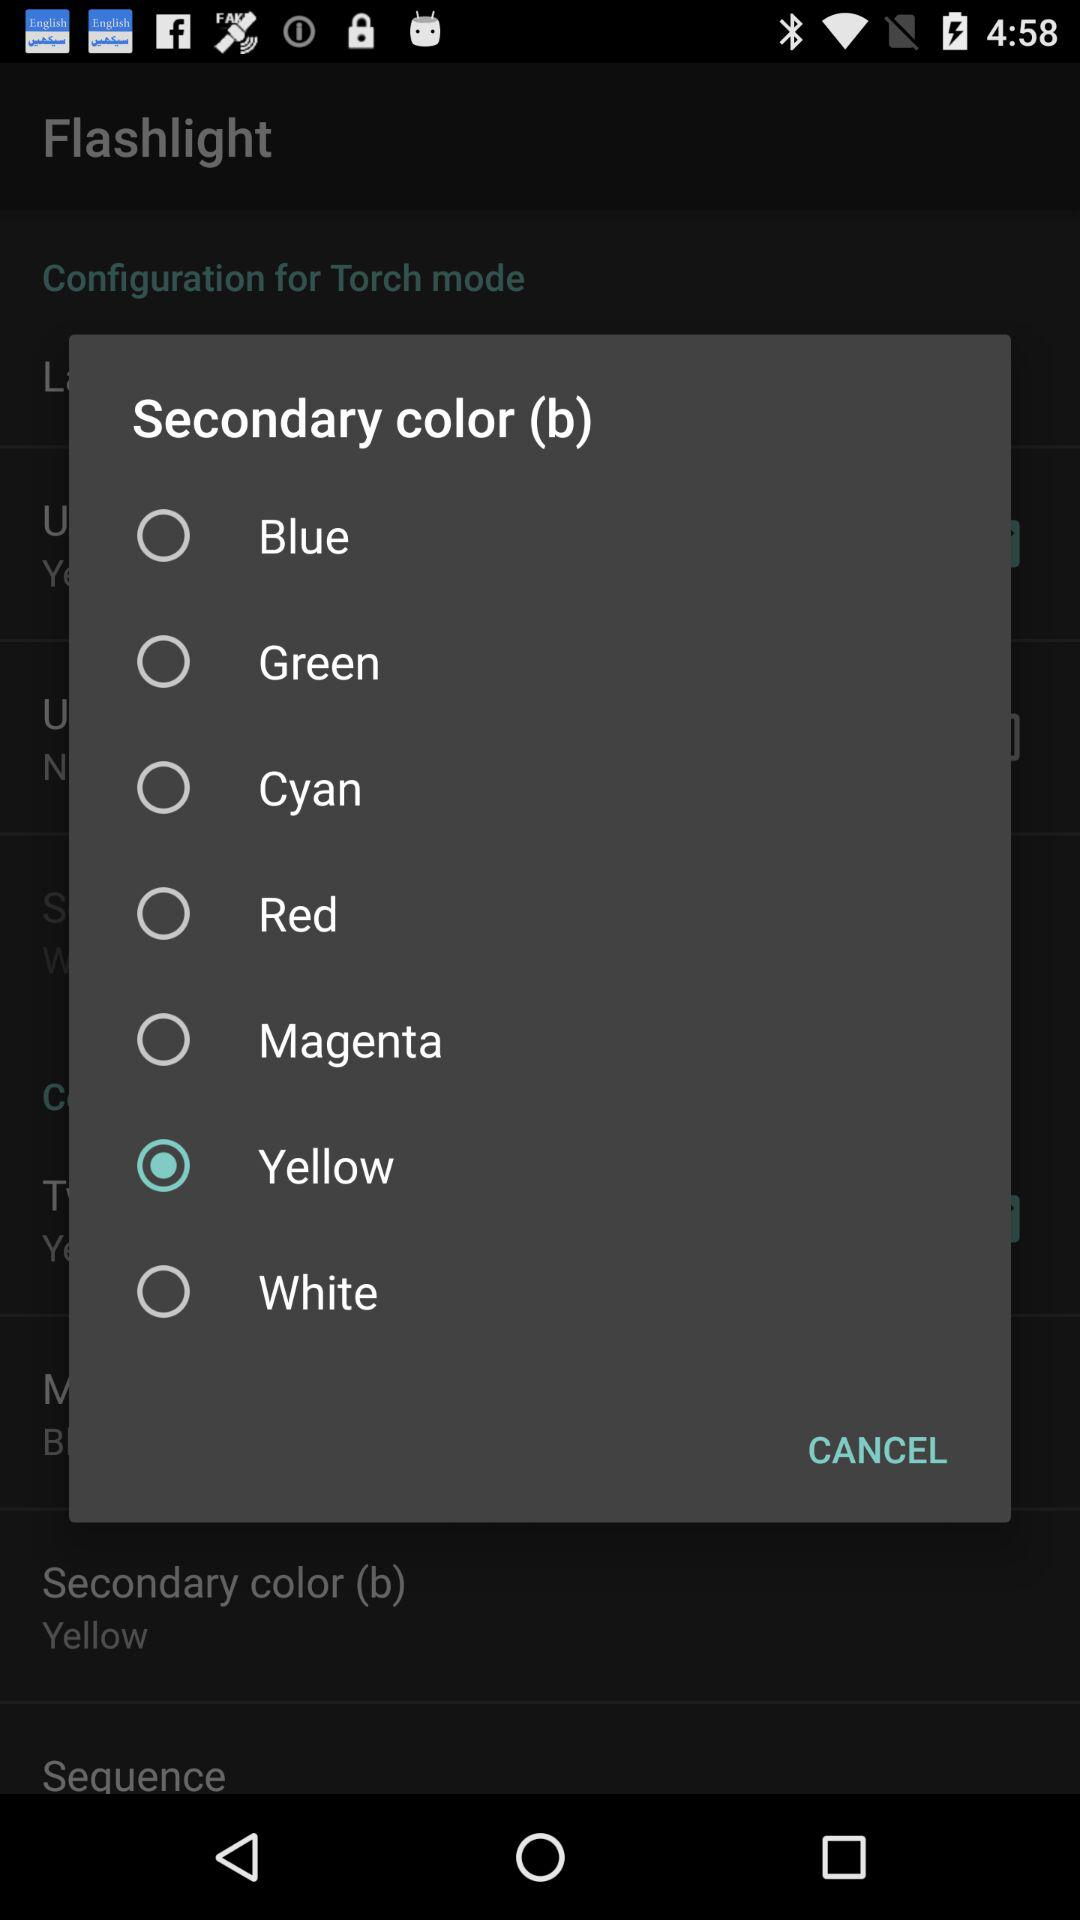Which color is selected? The selected color is yellow. 